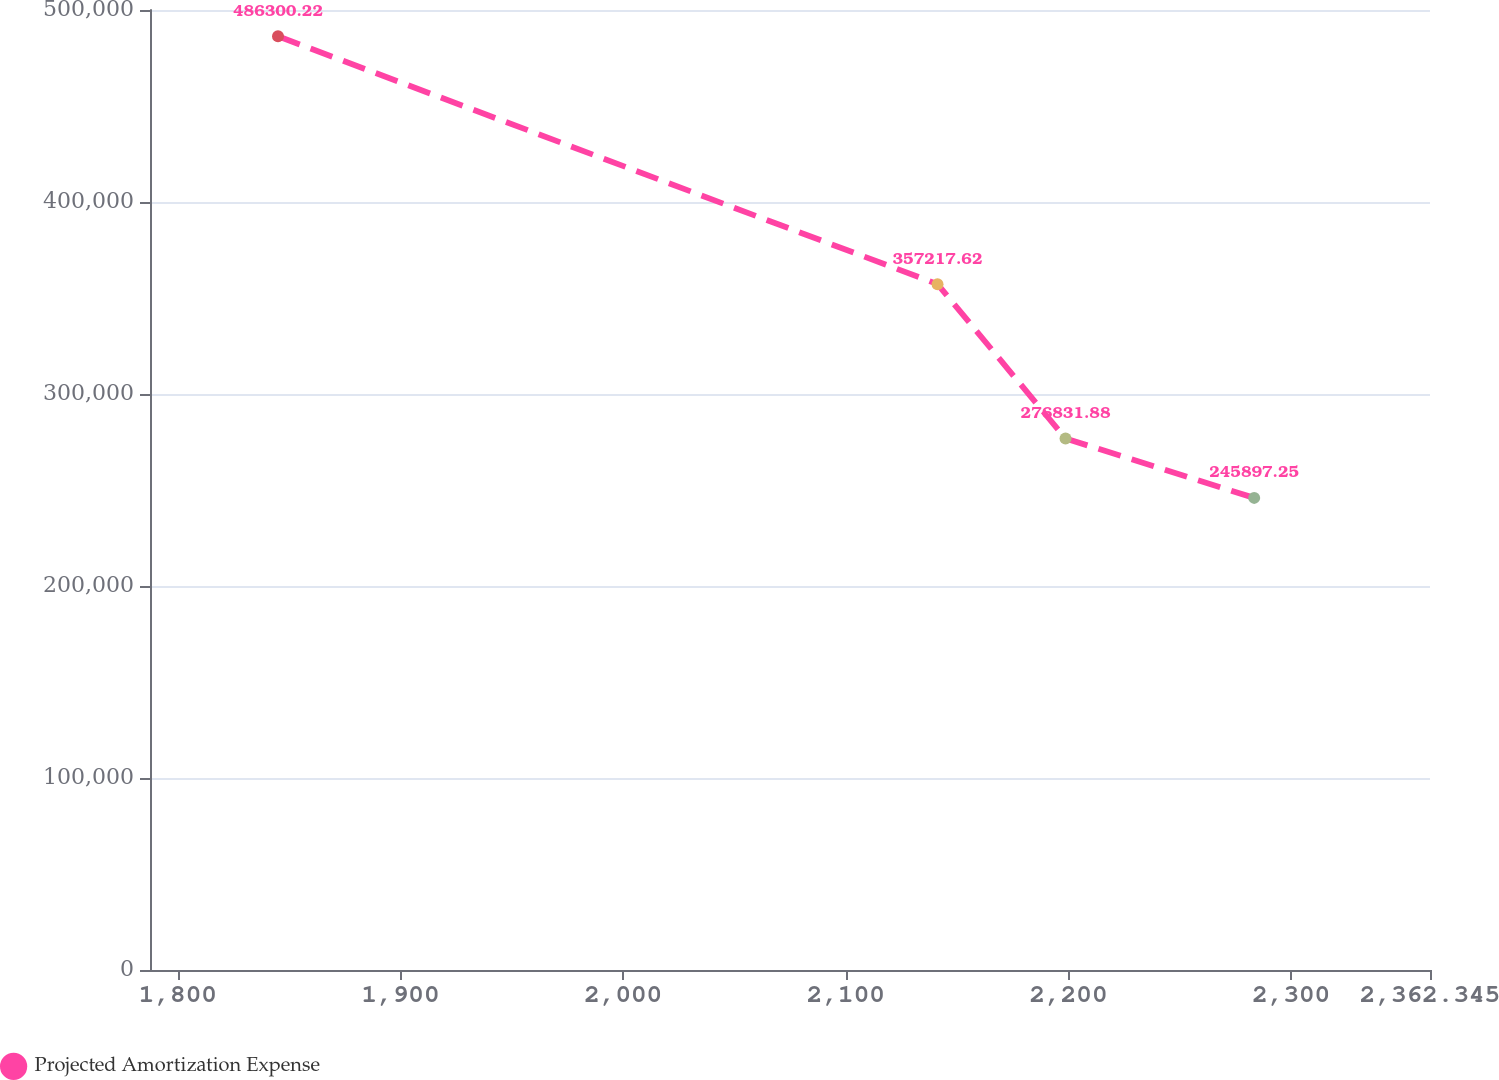Convert chart to OTSL. <chart><loc_0><loc_0><loc_500><loc_500><line_chart><ecel><fcel>Projected Amortization Expense<nl><fcel>1844.98<fcel>486300<nl><fcel>2141.17<fcel>357218<nl><fcel>2198.66<fcel>276832<nl><fcel>2283.38<fcel>245897<nl><fcel>2419.83<fcel>176954<nl></chart> 